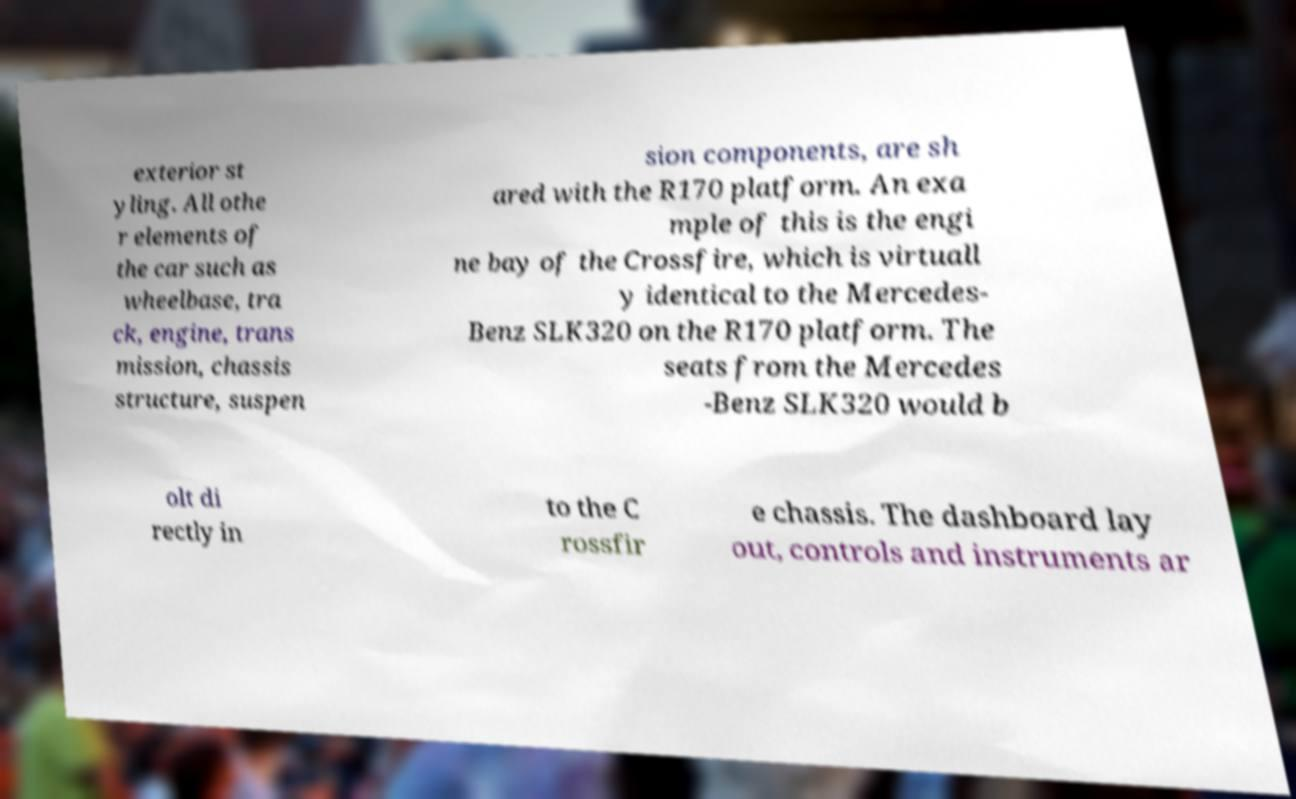Could you extract and type out the text from this image? exterior st yling. All othe r elements of the car such as wheelbase, tra ck, engine, trans mission, chassis structure, suspen sion components, are sh ared with the R170 platform. An exa mple of this is the engi ne bay of the Crossfire, which is virtuall y identical to the Mercedes- Benz SLK320 on the R170 platform. The seats from the Mercedes -Benz SLK320 would b olt di rectly in to the C rossfir e chassis. The dashboard lay out, controls and instruments ar 